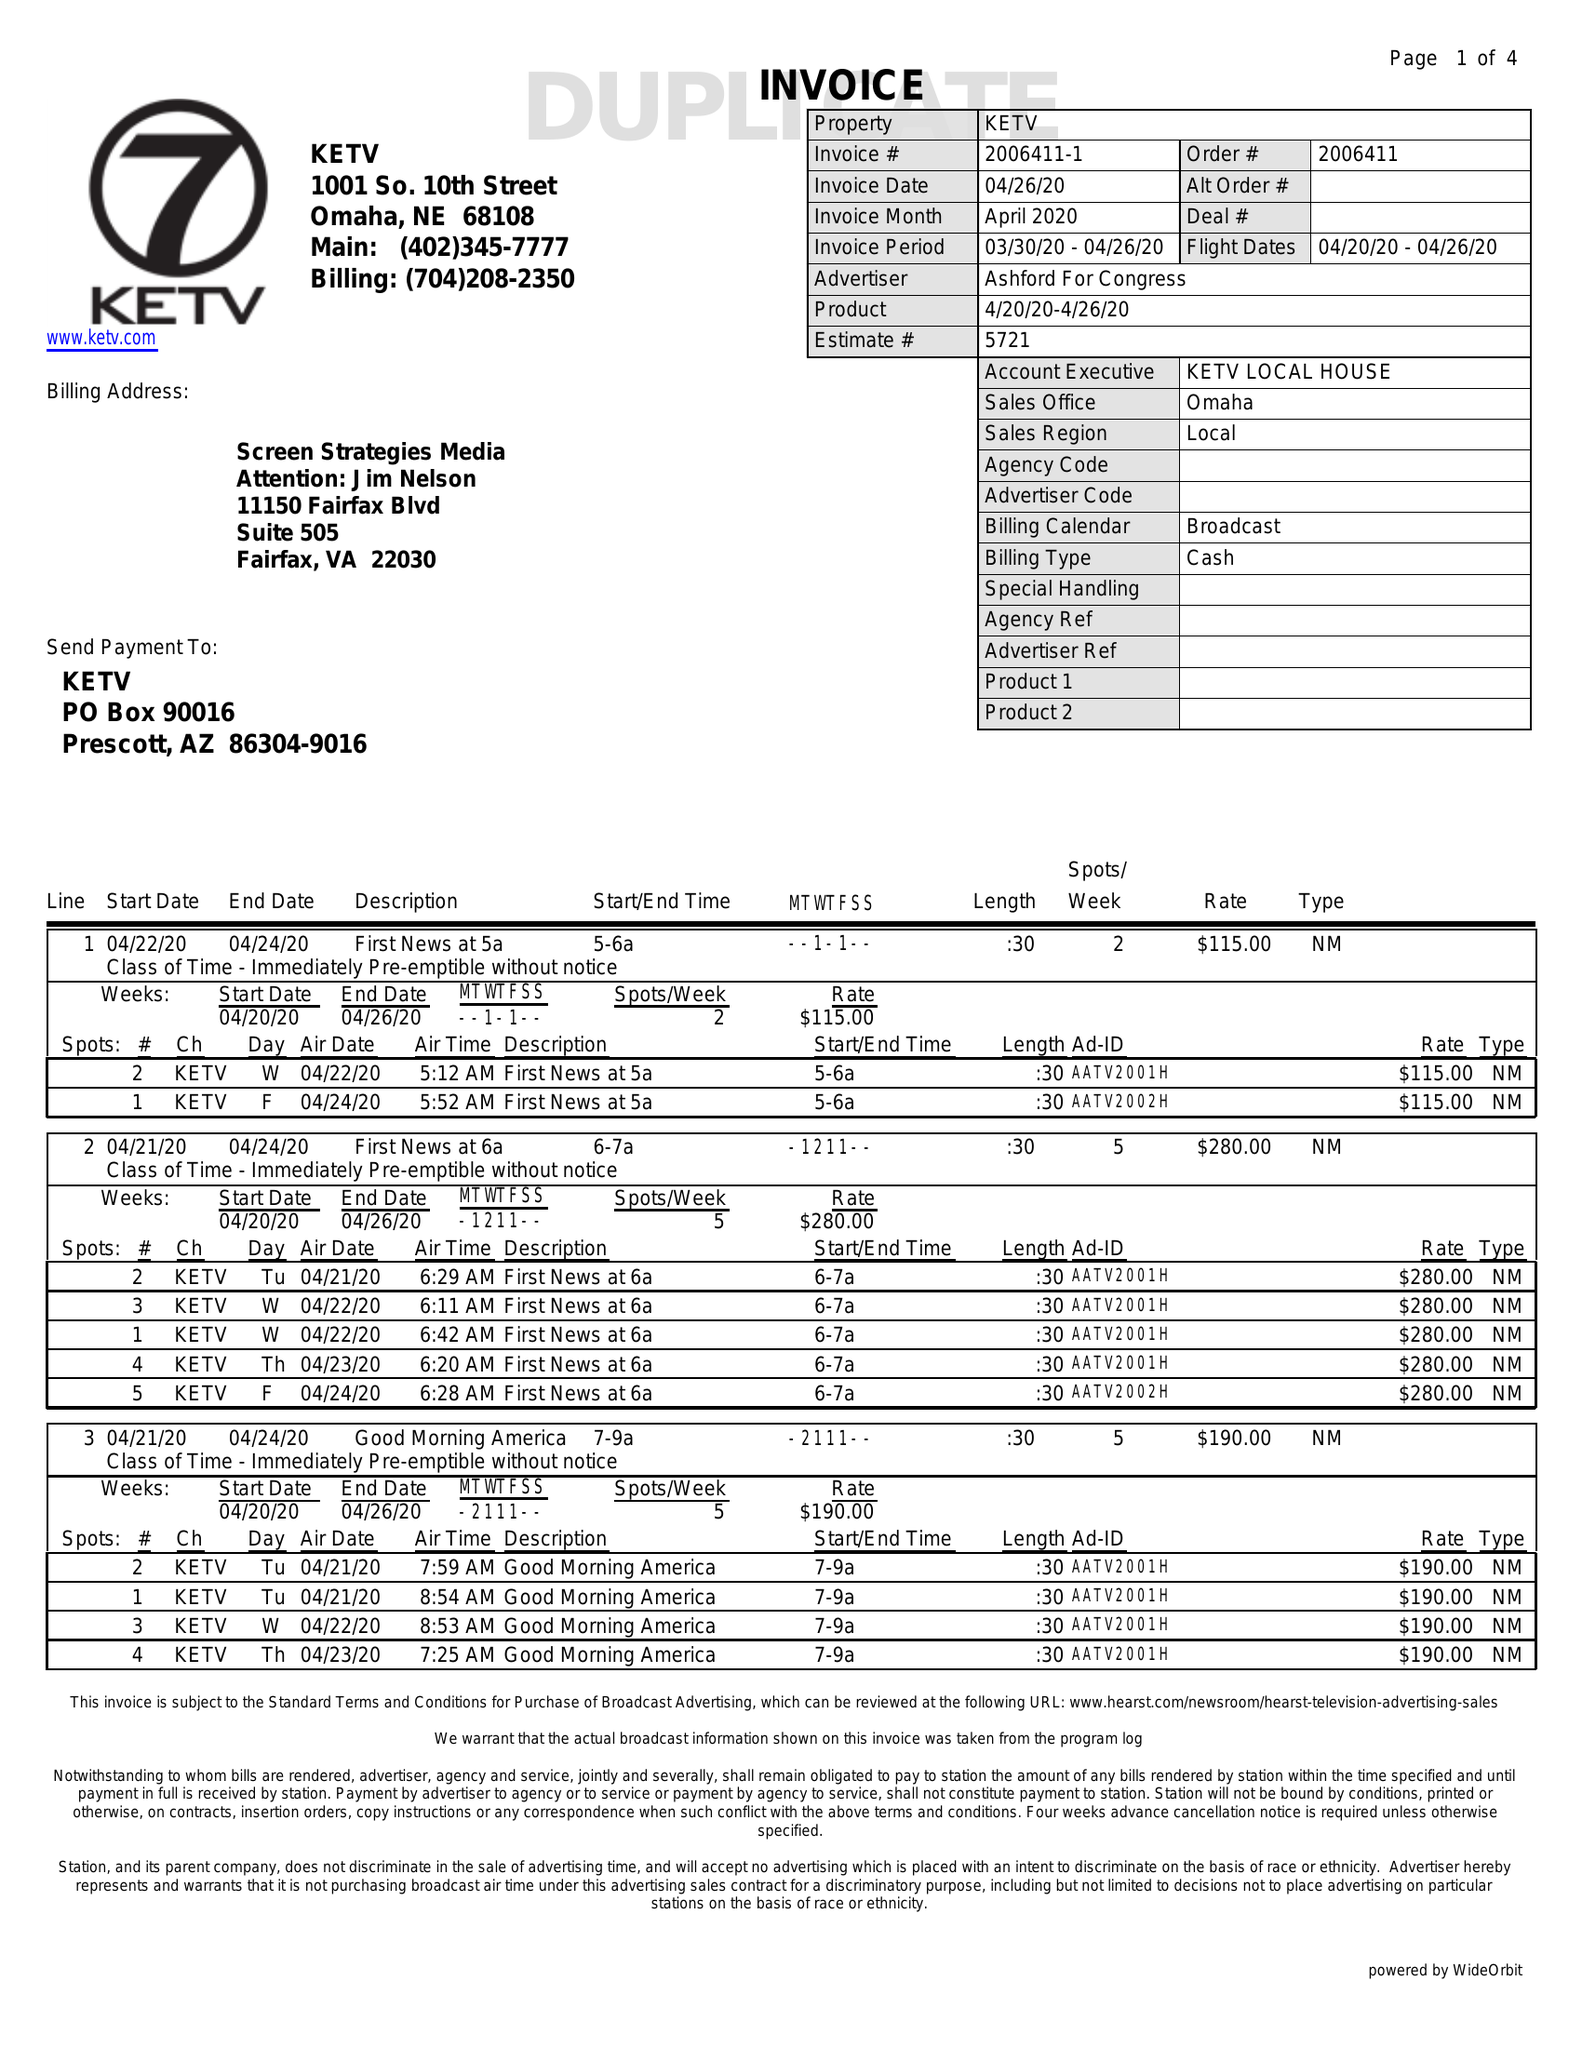What is the value for the flight_to?
Answer the question using a single word or phrase. 04/26/20 